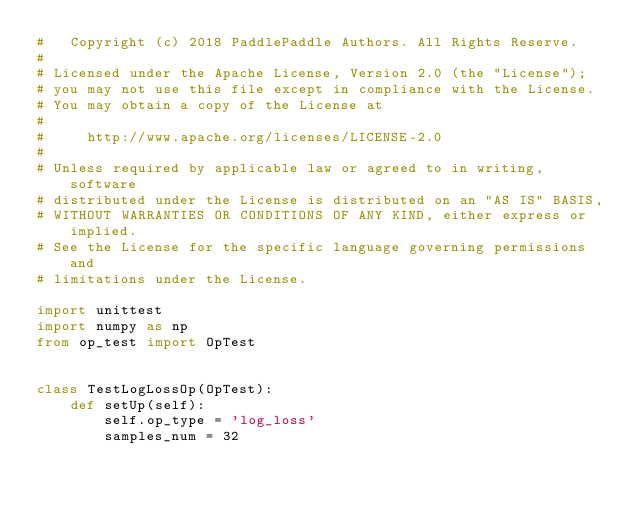Convert code to text. <code><loc_0><loc_0><loc_500><loc_500><_Python_>#   Copyright (c) 2018 PaddlePaddle Authors. All Rights Reserve.
#
# Licensed under the Apache License, Version 2.0 (the "License");
# you may not use this file except in compliance with the License.
# You may obtain a copy of the License at
#
#     http://www.apache.org/licenses/LICENSE-2.0
#
# Unless required by applicable law or agreed to in writing, software
# distributed under the License is distributed on an "AS IS" BASIS,
# WITHOUT WARRANTIES OR CONDITIONS OF ANY KIND, either express or implied.
# See the License for the specific language governing permissions and
# limitations under the License.

import unittest
import numpy as np
from op_test import OpTest


class TestLogLossOp(OpTest):
    def setUp(self):
        self.op_type = 'log_loss'
        samples_num = 32
</code> 